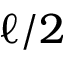Convert formula to latex. <formula><loc_0><loc_0><loc_500><loc_500>\ell / 2</formula> 